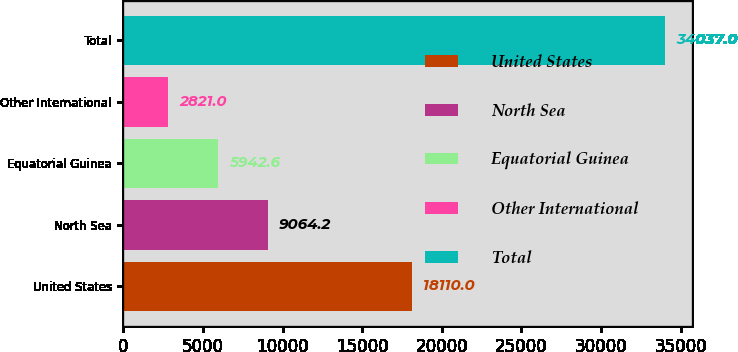<chart> <loc_0><loc_0><loc_500><loc_500><bar_chart><fcel>United States<fcel>North Sea<fcel>Equatorial Guinea<fcel>Other International<fcel>Total<nl><fcel>18110<fcel>9064.2<fcel>5942.6<fcel>2821<fcel>34037<nl></chart> 